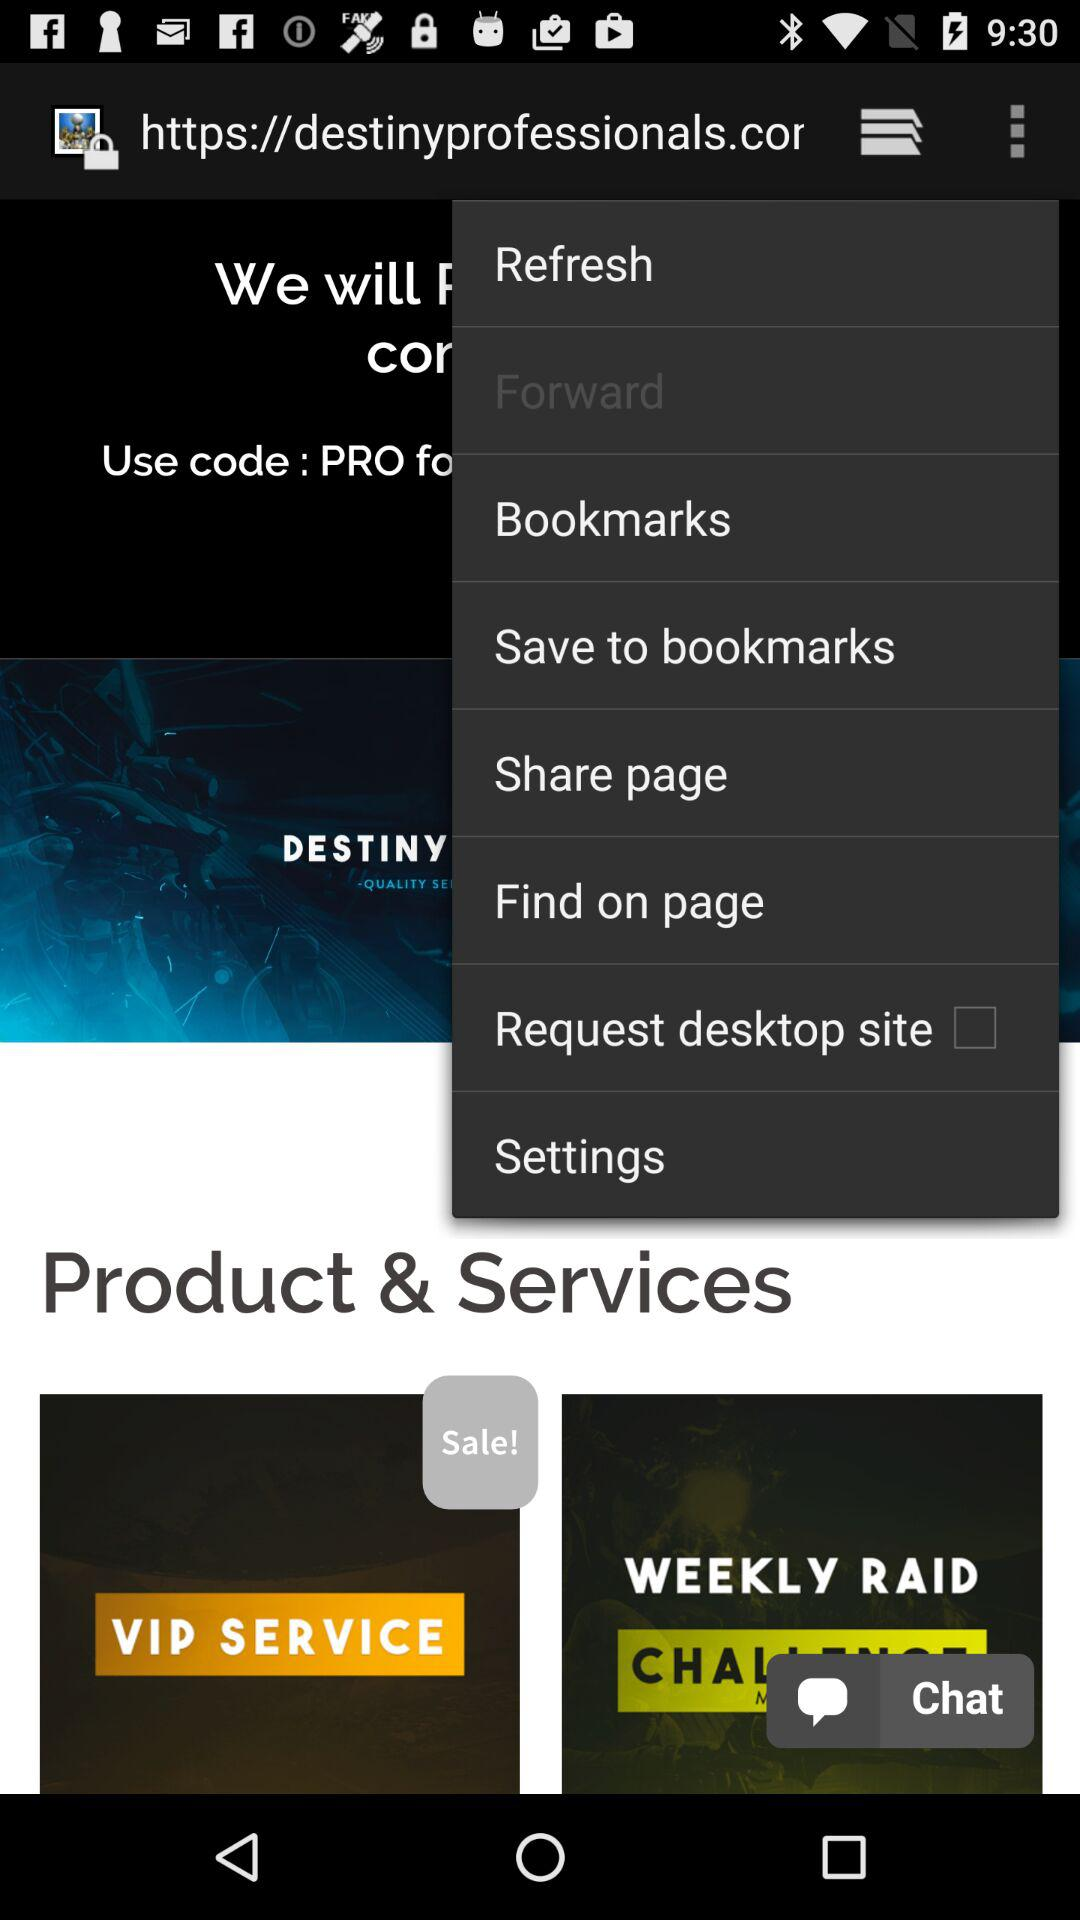Which products and services are on sale? The products and services that are on sale are "VIP SERVICE". 